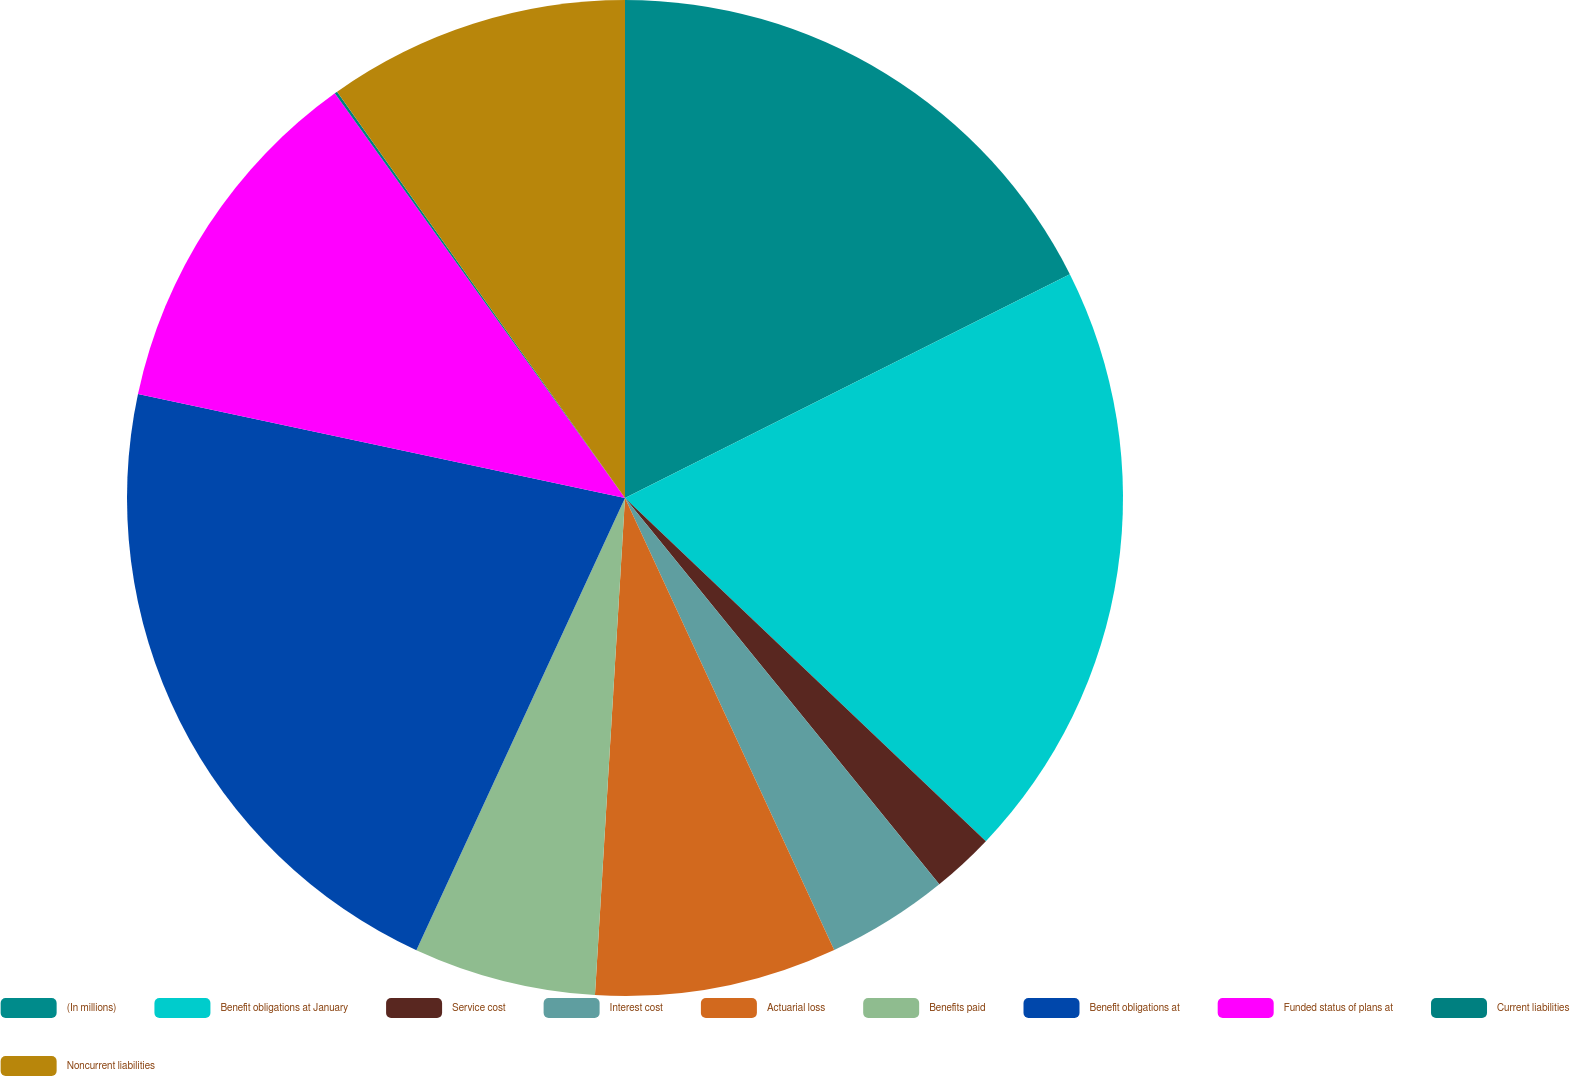Convert chart. <chart><loc_0><loc_0><loc_500><loc_500><pie_chart><fcel>(In millions)<fcel>Benefit obligations at January<fcel>Service cost<fcel>Interest cost<fcel>Actuarial loss<fcel>Benefits paid<fcel>Benefit obligations at<fcel>Funded status of plans at<fcel>Current liabilities<fcel>Noncurrent liabilities<nl><fcel>17.58%<fcel>19.52%<fcel>2.03%<fcel>3.97%<fcel>7.86%<fcel>5.92%<fcel>21.47%<fcel>11.75%<fcel>0.09%<fcel>9.81%<nl></chart> 